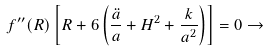Convert formula to latex. <formula><loc_0><loc_0><loc_500><loc_500>f ^ { \prime \prime } ( R ) \left [ R + 6 \left ( \frac { \ddot { a } } { a } + H ^ { 2 } + \frac { k } { a ^ { 2 } } \right ) \right ] = 0 \rightarrow</formula> 